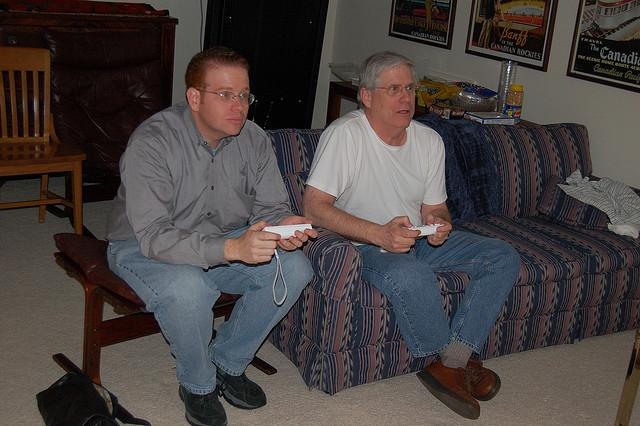What is the name of the white device in the men's hands?

Choices:
A) game controller
B) calculator
C) tv remote
D) phone game controller 